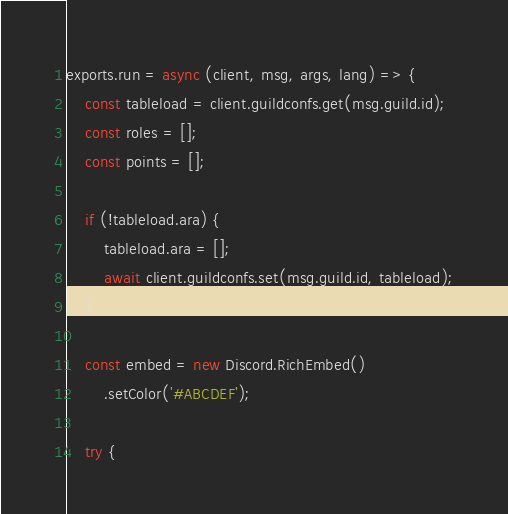Convert code to text. <code><loc_0><loc_0><loc_500><loc_500><_JavaScript_>exports.run = async (client, msg, args, lang) => {
	const tableload = client.guildconfs.get(msg.guild.id);
	const roles = [];
	const points = [];

	if (!tableload.ara) {
		tableload.ara = [];
		await client.guildconfs.set(msg.guild.id, tableload);
	}

	const embed = new Discord.RichEmbed()
		.setColor('#ABCDEF');

	try {</code> 